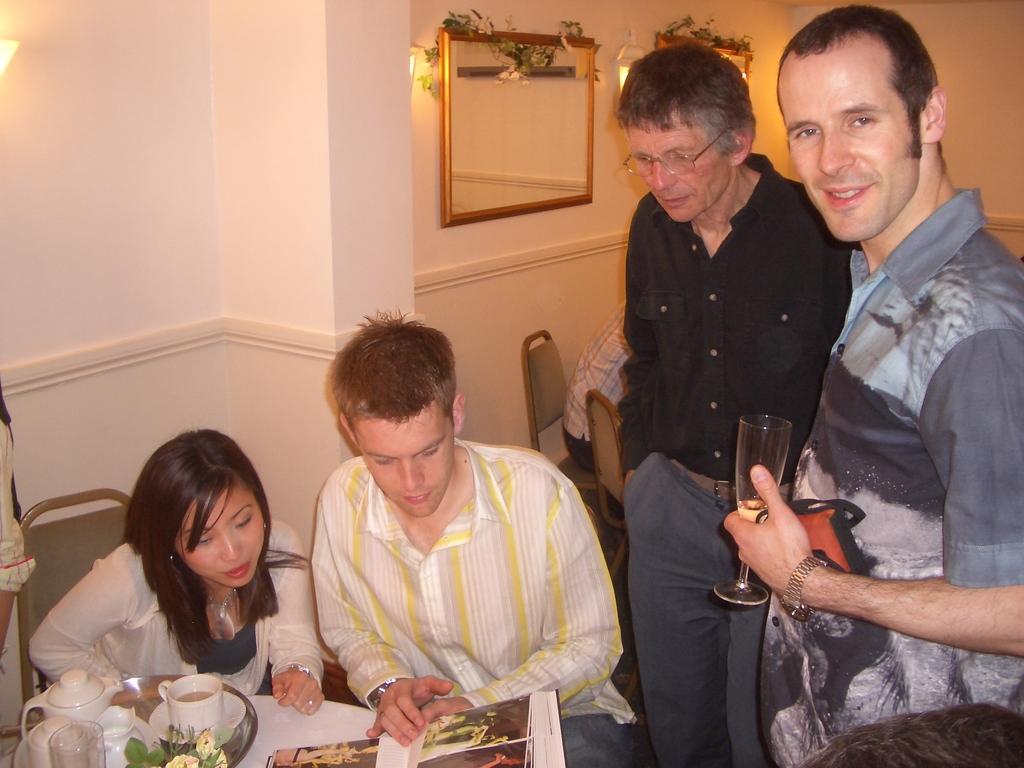How would you summarize this image in a sentence or two? In the image we can see there are people sitting and two of them are standing, they are wearing clothes. There is a person on the right side of the image wearing wrist watch and the person is smiling. Here we can see a mirror, lights and the wall. Here we can see the table, on the table there is a book, plate, glass, flowers and on the plate there is a cup, saucer and teapot. 